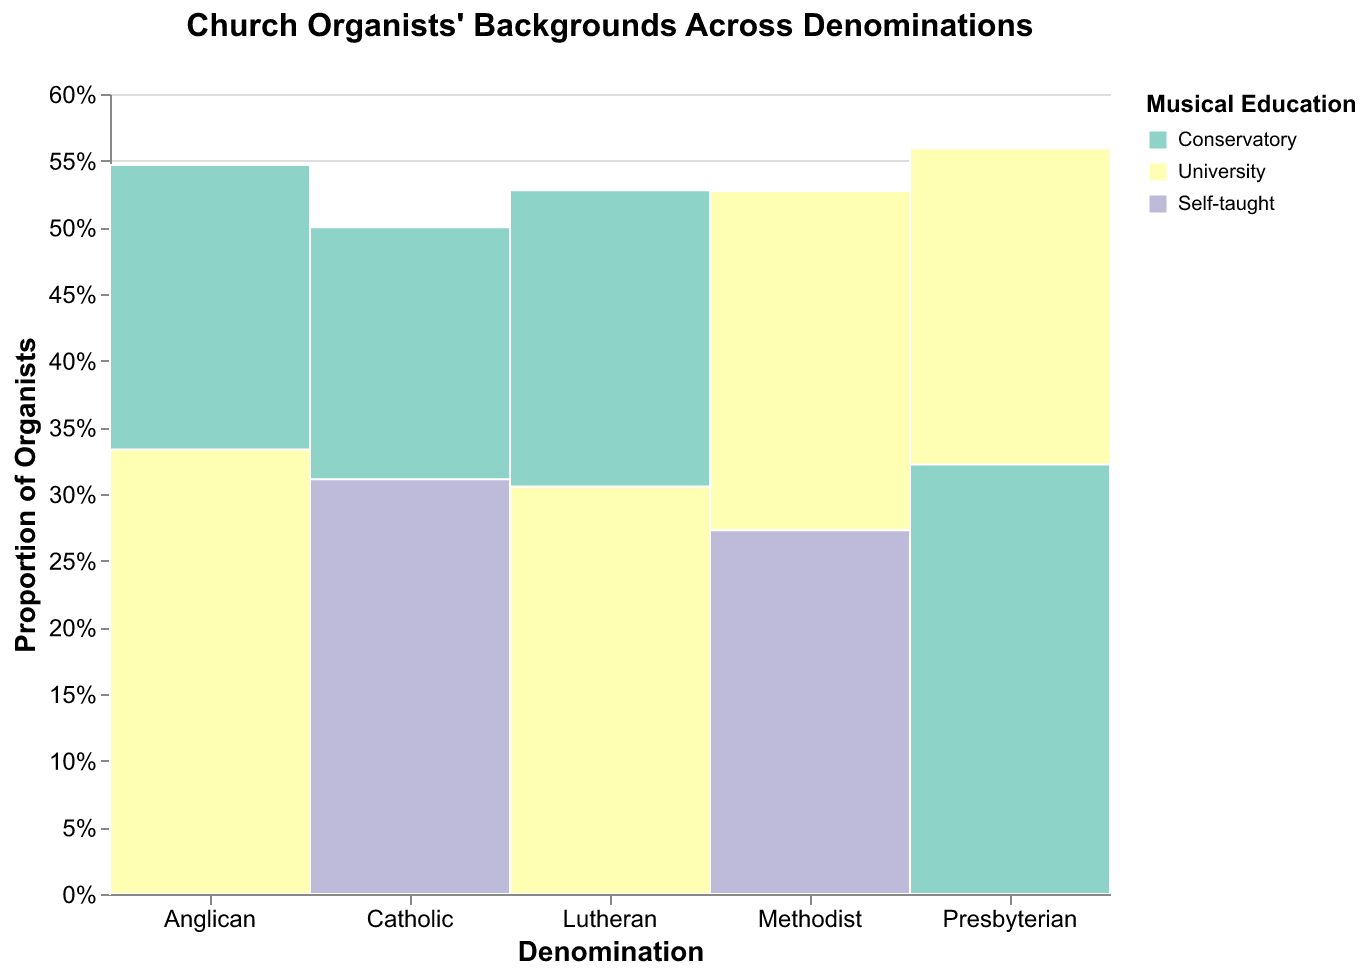What is the title of the figure? The title is usually at the top of the figure. It helps provide context for what the figure is illustrating. The figure title is "Church Organists' Backgrounds Across Denominations".
Answer: Church Organists' Backgrounds Across Denominations Which denomination has the highest proportion of organists with a conservatory background? You need to look at each segment for "Conservatory" across the different denominations and compare their sizes. The largest segment for "Conservatory" appears to be in the "Catholic" denomination.
Answer: Catholic What is the proportion of Lutheran organists with more than 10 years of experience? Identify the segment for "Lutheran" with "10+" years of experience and sum the proportions for each musical education background. Since "10+" for "Conservatory" in Lutheran is shown, this proportion itself answers the question.
Answer: The proportion is shown by the height of the "Conservatory" 10+ years bar within the Lutheran denomination Which denomination has the lowest total number of organists? To determine this, compare the overall height of bars for each denomination. The smallest total bar height belongs to the "Methodist" denomination.
Answer: Methodist How many denominations have a significant proportion of self-taught organists with 0-5 years of experience? Identify the segments labeled "Self-taught" and "0-5" years of experience in each denomination. Count the denominations where these segments are visibly present and notable. Looking at the chart, "Lutheran", "Anglican", "Presbyterian", and "Methodist" have noticeable segments.
Answer: Four denominations Which musical education background is the most common among organists with 5-10 years of experience in the Presbyterian denomination? In the Presbyterian bar, identify the segments labeled "5-10" years of experience and see which musical education background segment is larger. "University" has the largest segment in this category.
Answer: University How does the proportion of university-educated organists with over 10 years of experience compare between the Presbyterian and Methodist denominations? Compare the specific segments for "University" with "10+" years of experience in both Presbyterian and Methodist denominations. The figure shows that the Presbyterian segment is larger than the Methodist segment.
Answer: Presbyterian has a higher proportion Which denomination has the highest proportion of organists with conservatory education? Assess the proportion of organists with conservatory education in all denominations. The largest proportion is for the Catholic denomination.
Answer: Catholic What is the distribution of years of experience among Anglican organists? Look at the segments for the Anglican denomination and check the sizes of segments representing different years of experience ("0-5", "5-10", "10+"). The largest segment is "10+", followed by "5-10", and the smallest is "0-5".
Answer: 10+ > 5-10 > 0-5 